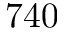Convert formula to latex. <formula><loc_0><loc_0><loc_500><loc_500>7 4 0</formula> 